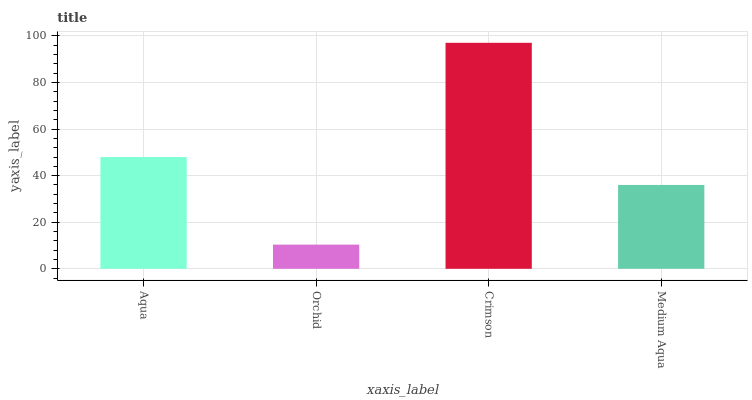Is Orchid the minimum?
Answer yes or no. Yes. Is Crimson the maximum?
Answer yes or no. Yes. Is Crimson the minimum?
Answer yes or no. No. Is Orchid the maximum?
Answer yes or no. No. Is Crimson greater than Orchid?
Answer yes or no. Yes. Is Orchid less than Crimson?
Answer yes or no. Yes. Is Orchid greater than Crimson?
Answer yes or no. No. Is Crimson less than Orchid?
Answer yes or no. No. Is Aqua the high median?
Answer yes or no. Yes. Is Medium Aqua the low median?
Answer yes or no. Yes. Is Crimson the high median?
Answer yes or no. No. Is Crimson the low median?
Answer yes or no. No. 